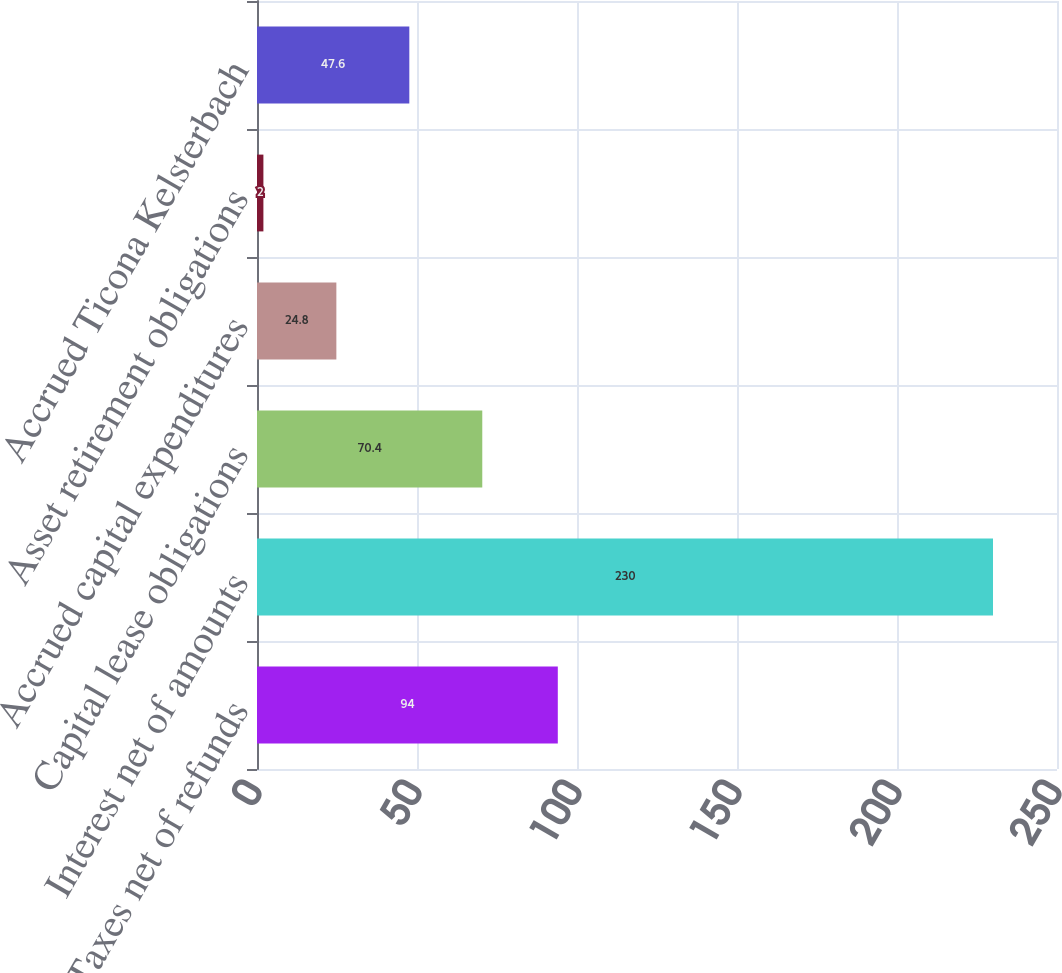Convert chart to OTSL. <chart><loc_0><loc_0><loc_500><loc_500><bar_chart><fcel>Taxes net of refunds<fcel>Interest net of amounts<fcel>Capital lease obligations<fcel>Accrued capital expenditures<fcel>Asset retirement obligations<fcel>Accrued Ticona Kelsterbach<nl><fcel>94<fcel>230<fcel>70.4<fcel>24.8<fcel>2<fcel>47.6<nl></chart> 